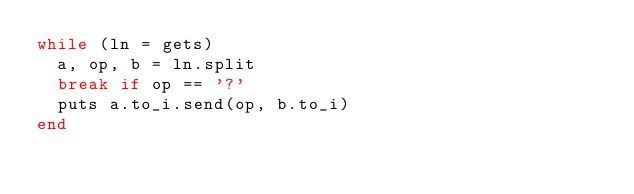<code> <loc_0><loc_0><loc_500><loc_500><_Ruby_>while (ln = gets)
  a, op, b = ln.split
  break if op == '?'
  puts a.to_i.send(op, b.to_i)
end</code> 